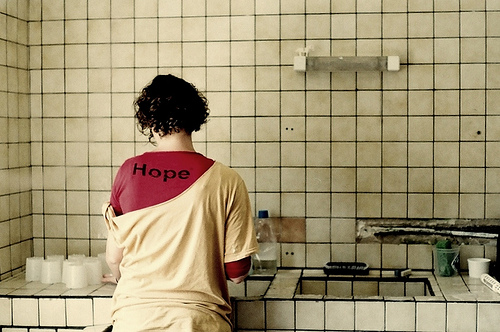<image>
Can you confirm if the lady is on the wall? No. The lady is not positioned on the wall. They may be near each other, but the lady is not supported by or resting on top of the wall. Is the cups in front of the sink? No. The cups is not in front of the sink. The spatial positioning shows a different relationship between these objects. 